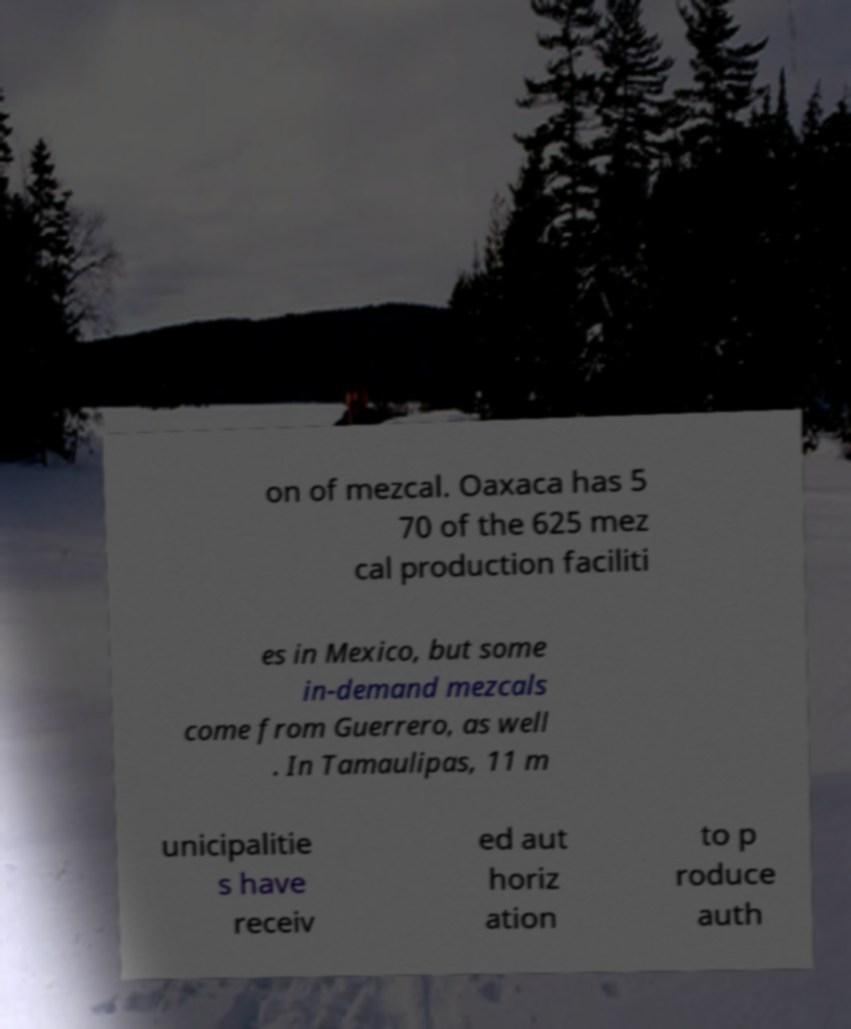Please identify and transcribe the text found in this image. on of mezcal. Oaxaca has 5 70 of the 625 mez cal production faciliti es in Mexico, but some in-demand mezcals come from Guerrero, as well . In Tamaulipas, 11 m unicipalitie s have receiv ed aut horiz ation to p roduce auth 